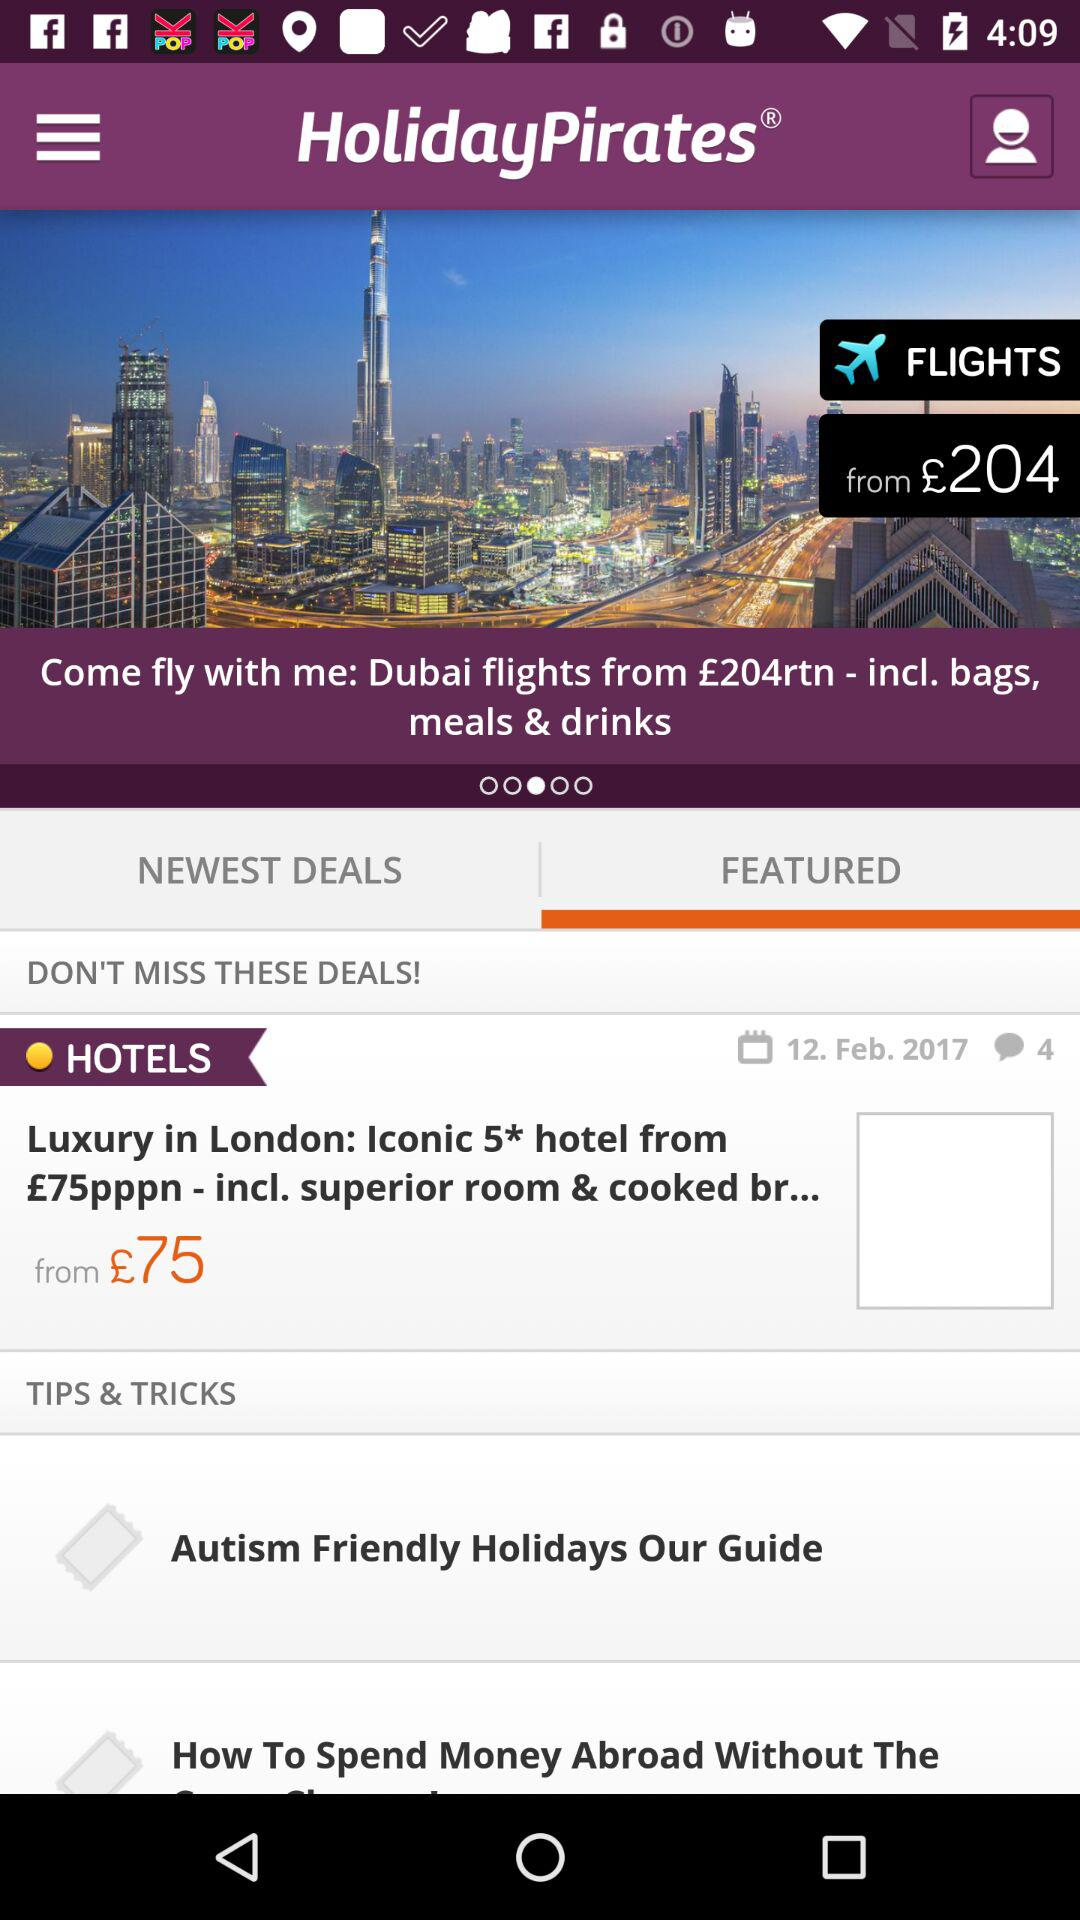How many comments are on "Autism Friendly Holidays Our Guide"?
When the provided information is insufficient, respond with <no answer>. <no answer> 